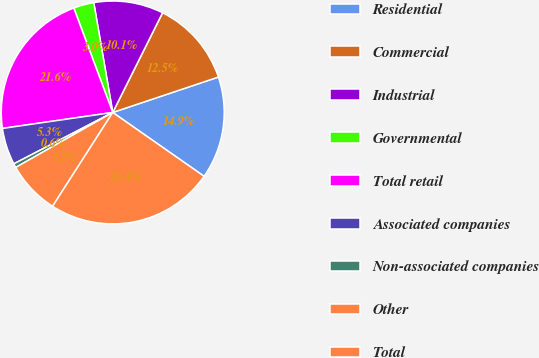<chart> <loc_0><loc_0><loc_500><loc_500><pie_chart><fcel>Residential<fcel>Commercial<fcel>Industrial<fcel>Governmental<fcel>Total retail<fcel>Associated companies<fcel>Non-associated companies<fcel>Other<fcel>Total<nl><fcel>14.86%<fcel>12.48%<fcel>10.1%<fcel>2.96%<fcel>21.61%<fcel>5.34%<fcel>0.58%<fcel>7.72%<fcel>24.37%<nl></chart> 